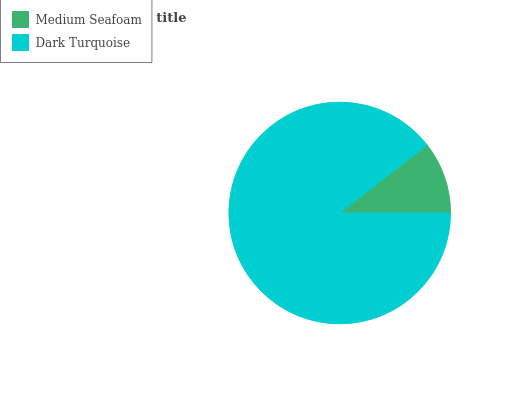Is Medium Seafoam the minimum?
Answer yes or no. Yes. Is Dark Turquoise the maximum?
Answer yes or no. Yes. Is Dark Turquoise the minimum?
Answer yes or no. No. Is Dark Turquoise greater than Medium Seafoam?
Answer yes or no. Yes. Is Medium Seafoam less than Dark Turquoise?
Answer yes or no. Yes. Is Medium Seafoam greater than Dark Turquoise?
Answer yes or no. No. Is Dark Turquoise less than Medium Seafoam?
Answer yes or no. No. Is Dark Turquoise the high median?
Answer yes or no. Yes. Is Medium Seafoam the low median?
Answer yes or no. Yes. Is Medium Seafoam the high median?
Answer yes or no. No. Is Dark Turquoise the low median?
Answer yes or no. No. 